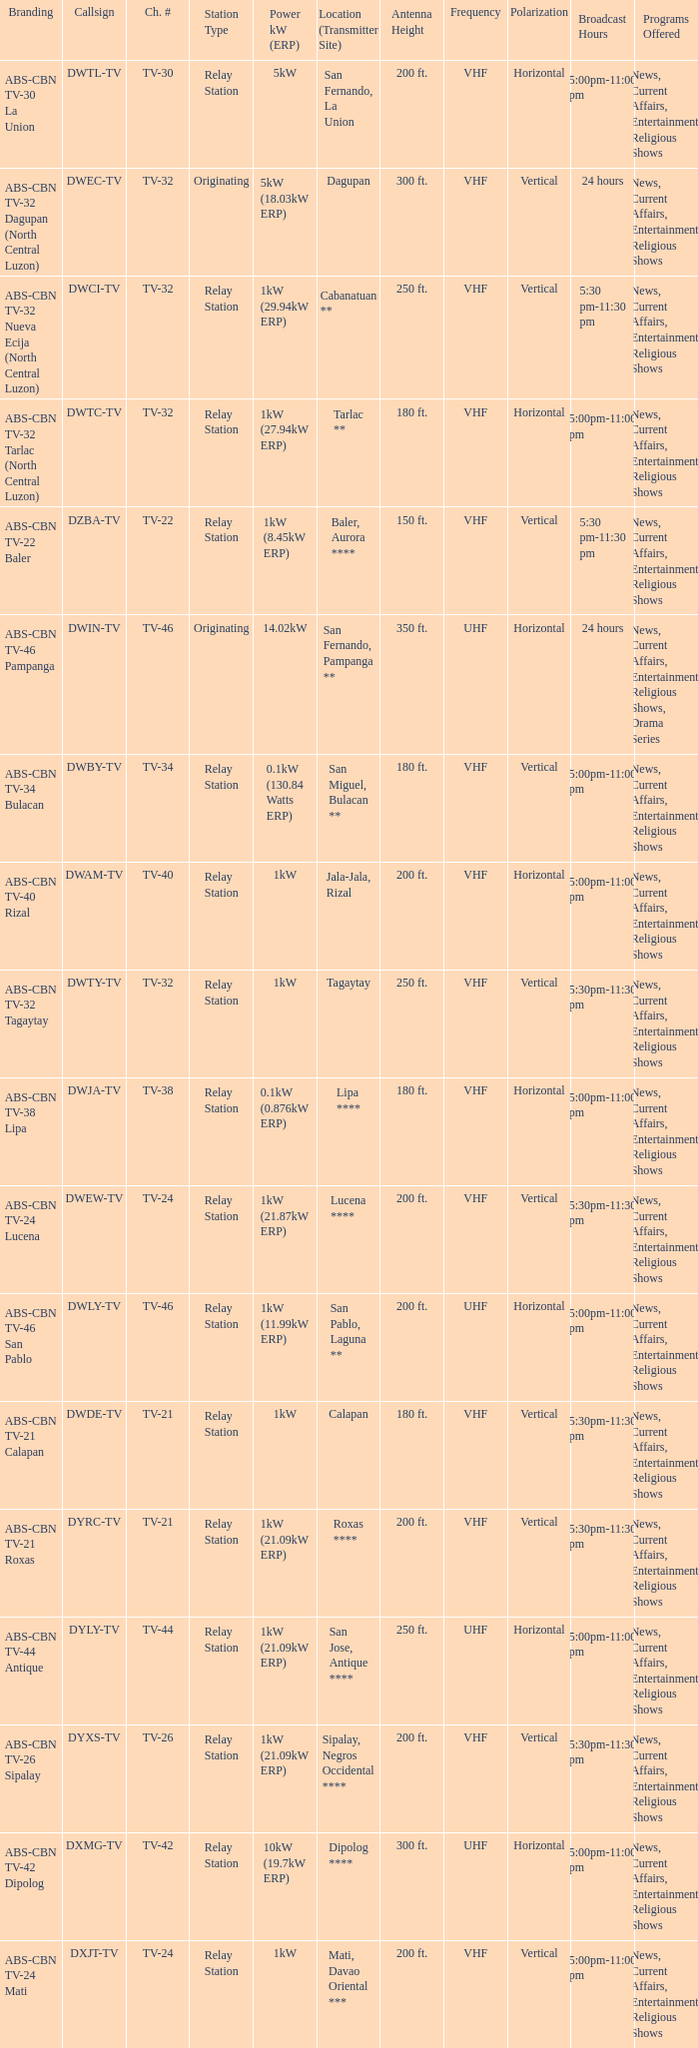The location (transmitter site) San Fernando, Pampanga ** has what Power kW (ERP)? 14.02kW. 